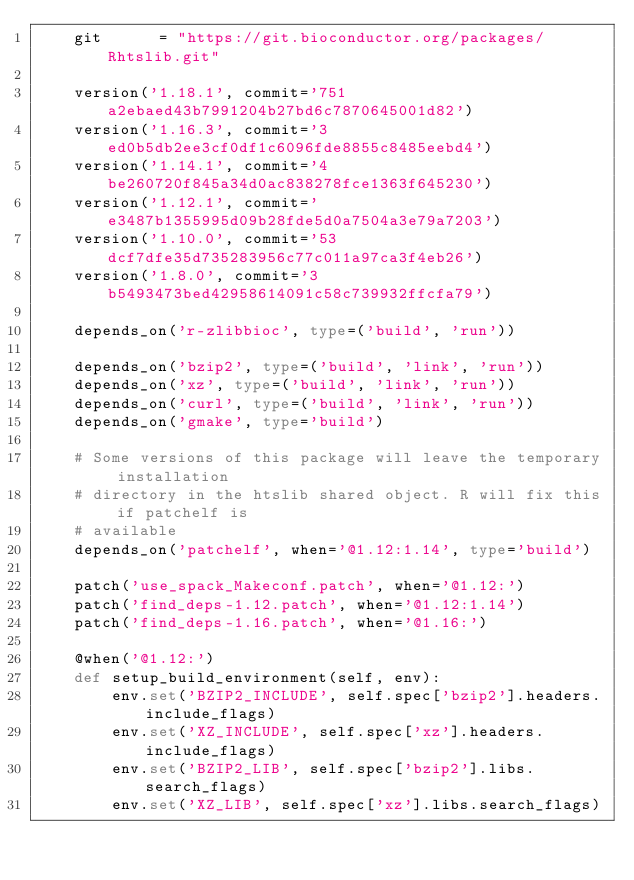<code> <loc_0><loc_0><loc_500><loc_500><_Python_>    git      = "https://git.bioconductor.org/packages/Rhtslib.git"

    version('1.18.1', commit='751a2ebaed43b7991204b27bd6c7870645001d82')
    version('1.16.3', commit='3ed0b5db2ee3cf0df1c6096fde8855c8485eebd4')
    version('1.14.1', commit='4be260720f845a34d0ac838278fce1363f645230')
    version('1.12.1', commit='e3487b1355995d09b28fde5d0a7504a3e79a7203')
    version('1.10.0', commit='53dcf7dfe35d735283956c77c011a97ca3f4eb26')
    version('1.8.0', commit='3b5493473bed42958614091c58c739932ffcfa79')

    depends_on('r-zlibbioc', type=('build', 'run'))

    depends_on('bzip2', type=('build', 'link', 'run'))
    depends_on('xz', type=('build', 'link', 'run'))
    depends_on('curl', type=('build', 'link', 'run'))
    depends_on('gmake', type='build')

    # Some versions of this package will leave the temporary installation
    # directory in the htslib shared object. R will fix this if patchelf is
    # available
    depends_on('patchelf', when='@1.12:1.14', type='build')

    patch('use_spack_Makeconf.patch', when='@1.12:')
    patch('find_deps-1.12.patch', when='@1.12:1.14')
    patch('find_deps-1.16.patch', when='@1.16:')

    @when('@1.12:')
    def setup_build_environment(self, env):
        env.set('BZIP2_INCLUDE', self.spec['bzip2'].headers.include_flags)
        env.set('XZ_INCLUDE', self.spec['xz'].headers.include_flags)
        env.set('BZIP2_LIB', self.spec['bzip2'].libs.search_flags)
        env.set('XZ_LIB', self.spec['xz'].libs.search_flags)
</code> 